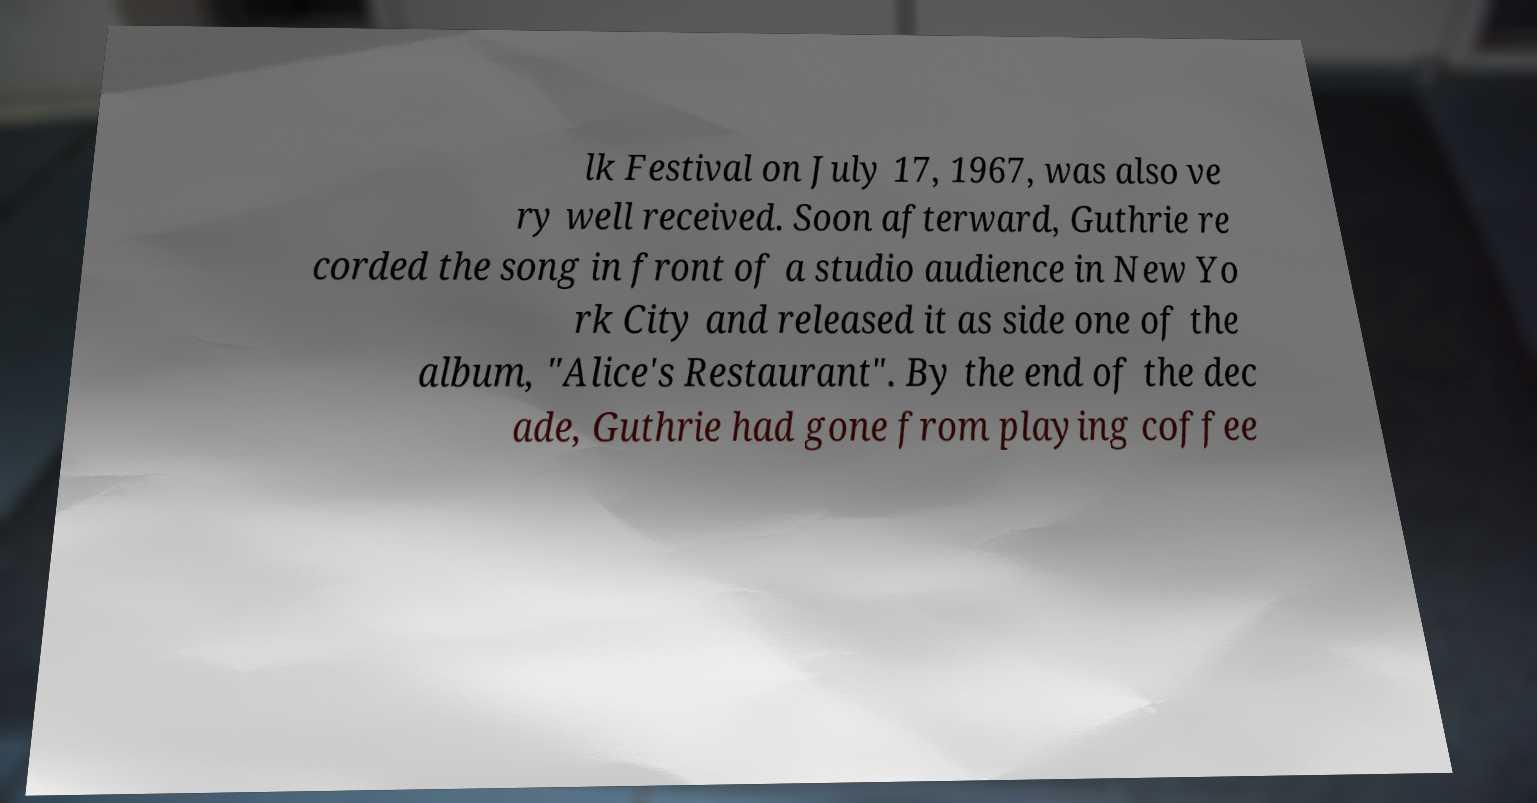Could you extract and type out the text from this image? lk Festival on July 17, 1967, was also ve ry well received. Soon afterward, Guthrie re corded the song in front of a studio audience in New Yo rk City and released it as side one of the album, "Alice's Restaurant". By the end of the dec ade, Guthrie had gone from playing coffee 